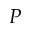Convert formula to latex. <formula><loc_0><loc_0><loc_500><loc_500>P</formula> 